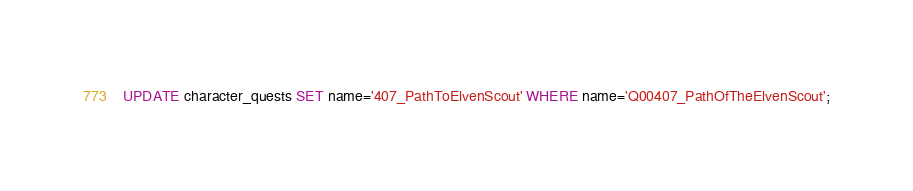<code> <loc_0><loc_0><loc_500><loc_500><_SQL_>UPDATE character_quests SET name='407_PathToElvenScout' WHERE name='Q00407_PathOfTheElvenScout';</code> 